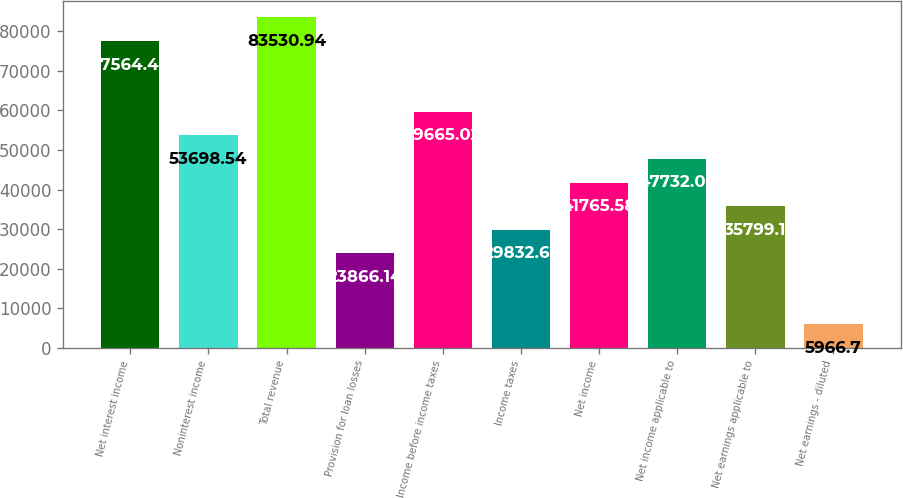Convert chart. <chart><loc_0><loc_0><loc_500><loc_500><bar_chart><fcel>Net interest income<fcel>Noninterest income<fcel>Total revenue<fcel>Provision for loan losses<fcel>Income before income taxes<fcel>Income taxes<fcel>Net income<fcel>Net income applicable to<fcel>Net earnings applicable to<fcel>Net earnings - diluted<nl><fcel>77564.5<fcel>53698.5<fcel>83530.9<fcel>23866.1<fcel>59665<fcel>29832.6<fcel>41765.6<fcel>47732.1<fcel>35799.1<fcel>5966.7<nl></chart> 